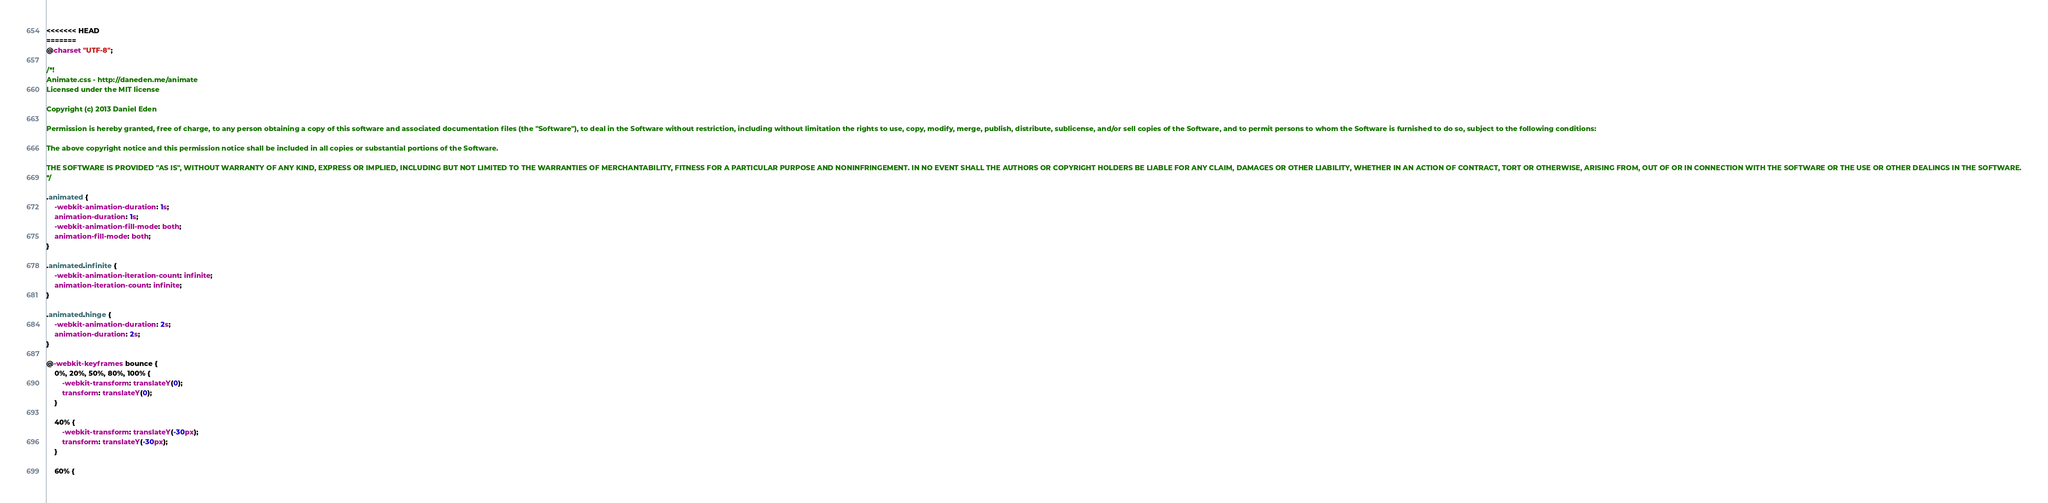<code> <loc_0><loc_0><loc_500><loc_500><_CSS_><<<<<<< HEAD
=======
@charset "UTF-8";

/*!
Animate.css - http://daneden.me/animate
Licensed under the MIT license

Copyright (c) 2013 Daniel Eden

Permission is hereby granted, free of charge, to any person obtaining a copy of this software and associated documentation files (the "Software"), to deal in the Software without restriction, including without limitation the rights to use, copy, modify, merge, publish, distribute, sublicense, and/or sell copies of the Software, and to permit persons to whom the Software is furnished to do so, subject to the following conditions:

The above copyright notice and this permission notice shall be included in all copies or substantial portions of the Software.

THE SOFTWARE IS PROVIDED "AS IS", WITHOUT WARRANTY OF ANY KIND, EXPRESS OR IMPLIED, INCLUDING BUT NOT LIMITED TO THE WARRANTIES OF MERCHANTABILITY, FITNESS FOR A PARTICULAR PURPOSE AND NONINFRINGEMENT. IN NO EVENT SHALL THE AUTHORS OR COPYRIGHT HOLDERS BE LIABLE FOR ANY CLAIM, DAMAGES OR OTHER LIABILITY, WHETHER IN AN ACTION OF CONTRACT, TORT OR OTHERWISE, ARISING FROM, OUT OF OR IN CONNECTION WITH THE SOFTWARE OR THE USE OR OTHER DEALINGS IN THE SOFTWARE.
*/

.animated {
    -webkit-animation-duration: 1s;
    animation-duration: 1s;
    -webkit-animation-fill-mode: both;
    animation-fill-mode: both;
}

.animated.infinite {
    -webkit-animation-iteration-count: infinite;
    animation-iteration-count: infinite;
}

.animated.hinge {
    -webkit-animation-duration: 2s;
    animation-duration: 2s;
}

@-webkit-keyframes bounce {
    0%, 20%, 50%, 80%, 100% {
        -webkit-transform: translateY(0);
        transform: translateY(0);
    }

    40% {
        -webkit-transform: translateY(-30px);
        transform: translateY(-30px);
    }

    60% {</code> 